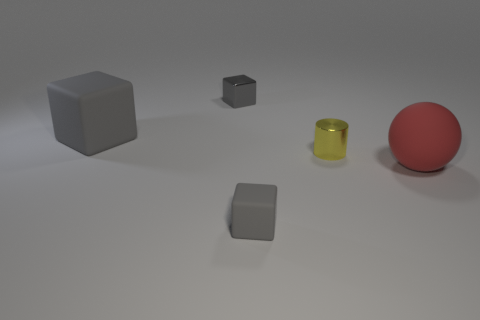There is a rubber object that is on the right side of the cube in front of the small cylinder; what color is it?
Provide a short and direct response. Red. What is the color of the matte object that is the same size as the yellow metallic cylinder?
Offer a very short reply. Gray. Is there another gray metal thing of the same shape as the small gray metallic thing?
Offer a very short reply. No. What is the shape of the red matte object?
Your response must be concise. Sphere. Is the number of large rubber objects that are behind the small gray shiny cube greater than the number of small cylinders on the right side of the large red sphere?
Provide a succinct answer. No. How many other things are the same size as the red sphere?
Provide a short and direct response. 1. What material is the object that is to the right of the small matte block and in front of the yellow metallic cylinder?
Your answer should be compact. Rubber. There is another small object that is the same shape as the tiny rubber thing; what is it made of?
Ensure brevity in your answer.  Metal. There is a gray matte cube that is behind the large matte object that is in front of the big gray cube; how many big red matte balls are behind it?
Keep it short and to the point. 0. Are there any other things of the same color as the metallic cylinder?
Ensure brevity in your answer.  No. 